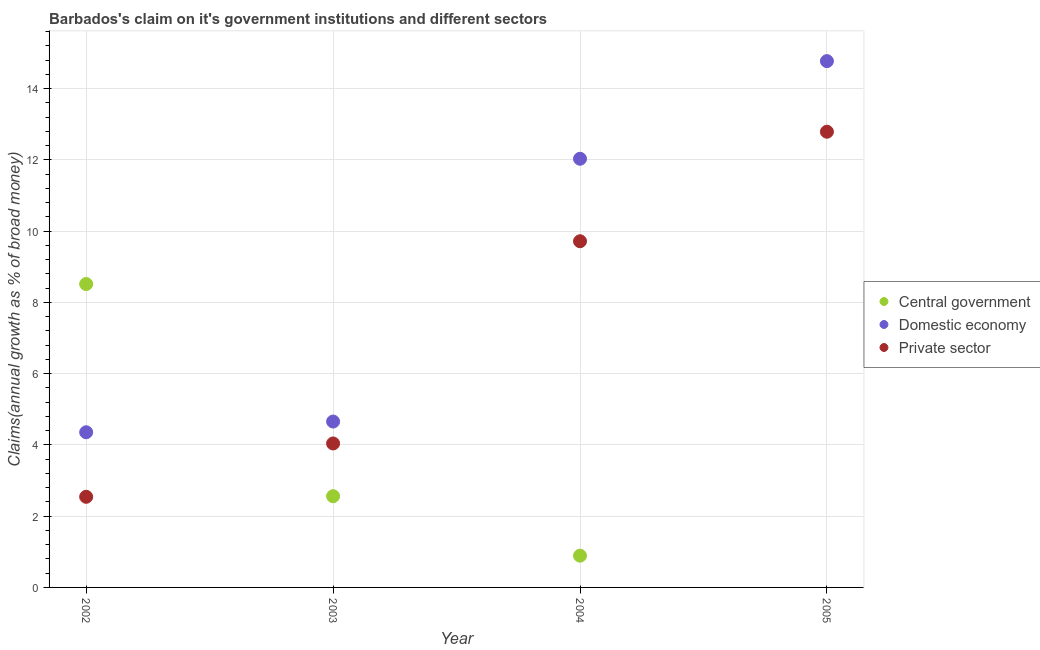Is the number of dotlines equal to the number of legend labels?
Give a very brief answer. No. What is the percentage of claim on the domestic economy in 2002?
Your answer should be very brief. 4.35. Across all years, what is the maximum percentage of claim on the central government?
Ensure brevity in your answer.  8.51. Across all years, what is the minimum percentage of claim on the domestic economy?
Give a very brief answer. 4.35. What is the total percentage of claim on the central government in the graph?
Ensure brevity in your answer.  11.97. What is the difference between the percentage of claim on the domestic economy in 2002 and that in 2004?
Your response must be concise. -7.68. What is the difference between the percentage of claim on the central government in 2003 and the percentage of claim on the private sector in 2004?
Give a very brief answer. -7.15. What is the average percentage of claim on the central government per year?
Your answer should be very brief. 2.99. In the year 2005, what is the difference between the percentage of claim on the domestic economy and percentage of claim on the private sector?
Your answer should be compact. 1.98. What is the ratio of the percentage of claim on the private sector in 2003 to that in 2005?
Offer a terse response. 0.32. Is the percentage of claim on the private sector in 2003 less than that in 2004?
Make the answer very short. Yes. What is the difference between the highest and the second highest percentage of claim on the domestic economy?
Provide a short and direct response. 2.74. What is the difference between the highest and the lowest percentage of claim on the domestic economy?
Your response must be concise. 10.42. Is the sum of the percentage of claim on the central government in 2002 and 2003 greater than the maximum percentage of claim on the domestic economy across all years?
Ensure brevity in your answer.  No. Is it the case that in every year, the sum of the percentage of claim on the central government and percentage of claim on the domestic economy is greater than the percentage of claim on the private sector?
Your answer should be very brief. Yes. Does the percentage of claim on the private sector monotonically increase over the years?
Give a very brief answer. Yes. Is the percentage of claim on the private sector strictly less than the percentage of claim on the central government over the years?
Offer a very short reply. No. How many years are there in the graph?
Give a very brief answer. 4. What is the difference between two consecutive major ticks on the Y-axis?
Ensure brevity in your answer.  2. Where does the legend appear in the graph?
Keep it short and to the point. Center right. How many legend labels are there?
Offer a very short reply. 3. What is the title of the graph?
Give a very brief answer. Barbados's claim on it's government institutions and different sectors. What is the label or title of the X-axis?
Ensure brevity in your answer.  Year. What is the label or title of the Y-axis?
Give a very brief answer. Claims(annual growth as % of broad money). What is the Claims(annual growth as % of broad money) of Central government in 2002?
Offer a terse response. 8.51. What is the Claims(annual growth as % of broad money) of Domestic economy in 2002?
Your answer should be compact. 4.35. What is the Claims(annual growth as % of broad money) of Private sector in 2002?
Offer a terse response. 2.54. What is the Claims(annual growth as % of broad money) of Central government in 2003?
Your response must be concise. 2.56. What is the Claims(annual growth as % of broad money) of Domestic economy in 2003?
Offer a terse response. 4.66. What is the Claims(annual growth as % of broad money) of Private sector in 2003?
Offer a terse response. 4.04. What is the Claims(annual growth as % of broad money) in Central government in 2004?
Your answer should be very brief. 0.89. What is the Claims(annual growth as % of broad money) in Domestic economy in 2004?
Keep it short and to the point. 12.03. What is the Claims(annual growth as % of broad money) in Private sector in 2004?
Offer a very short reply. 9.72. What is the Claims(annual growth as % of broad money) in Central government in 2005?
Offer a terse response. 0. What is the Claims(annual growth as % of broad money) in Domestic economy in 2005?
Offer a terse response. 14.77. What is the Claims(annual growth as % of broad money) of Private sector in 2005?
Keep it short and to the point. 12.79. Across all years, what is the maximum Claims(annual growth as % of broad money) of Central government?
Your answer should be compact. 8.51. Across all years, what is the maximum Claims(annual growth as % of broad money) in Domestic economy?
Offer a very short reply. 14.77. Across all years, what is the maximum Claims(annual growth as % of broad money) in Private sector?
Make the answer very short. 12.79. Across all years, what is the minimum Claims(annual growth as % of broad money) in Central government?
Your answer should be very brief. 0. Across all years, what is the minimum Claims(annual growth as % of broad money) of Domestic economy?
Offer a very short reply. 4.35. Across all years, what is the minimum Claims(annual growth as % of broad money) of Private sector?
Provide a succinct answer. 2.54. What is the total Claims(annual growth as % of broad money) of Central government in the graph?
Ensure brevity in your answer.  11.97. What is the total Claims(annual growth as % of broad money) in Domestic economy in the graph?
Offer a terse response. 35.81. What is the total Claims(annual growth as % of broad money) in Private sector in the graph?
Give a very brief answer. 29.09. What is the difference between the Claims(annual growth as % of broad money) of Central government in 2002 and that in 2003?
Give a very brief answer. 5.95. What is the difference between the Claims(annual growth as % of broad money) of Domestic economy in 2002 and that in 2003?
Offer a terse response. -0.3. What is the difference between the Claims(annual growth as % of broad money) of Private sector in 2002 and that in 2003?
Your answer should be compact. -1.5. What is the difference between the Claims(annual growth as % of broad money) in Central government in 2002 and that in 2004?
Offer a terse response. 7.62. What is the difference between the Claims(annual growth as % of broad money) in Domestic economy in 2002 and that in 2004?
Provide a succinct answer. -7.68. What is the difference between the Claims(annual growth as % of broad money) of Private sector in 2002 and that in 2004?
Provide a succinct answer. -7.17. What is the difference between the Claims(annual growth as % of broad money) of Domestic economy in 2002 and that in 2005?
Provide a succinct answer. -10.42. What is the difference between the Claims(annual growth as % of broad money) of Private sector in 2002 and that in 2005?
Ensure brevity in your answer.  -10.25. What is the difference between the Claims(annual growth as % of broad money) of Central government in 2003 and that in 2004?
Your answer should be very brief. 1.67. What is the difference between the Claims(annual growth as % of broad money) in Domestic economy in 2003 and that in 2004?
Make the answer very short. -7.37. What is the difference between the Claims(annual growth as % of broad money) in Private sector in 2003 and that in 2004?
Your response must be concise. -5.68. What is the difference between the Claims(annual growth as % of broad money) of Domestic economy in 2003 and that in 2005?
Keep it short and to the point. -10.12. What is the difference between the Claims(annual growth as % of broad money) of Private sector in 2003 and that in 2005?
Your answer should be very brief. -8.75. What is the difference between the Claims(annual growth as % of broad money) in Domestic economy in 2004 and that in 2005?
Your response must be concise. -2.74. What is the difference between the Claims(annual growth as % of broad money) of Private sector in 2004 and that in 2005?
Provide a succinct answer. -3.07. What is the difference between the Claims(annual growth as % of broad money) of Central government in 2002 and the Claims(annual growth as % of broad money) of Domestic economy in 2003?
Your answer should be compact. 3.86. What is the difference between the Claims(annual growth as % of broad money) in Central government in 2002 and the Claims(annual growth as % of broad money) in Private sector in 2003?
Make the answer very short. 4.47. What is the difference between the Claims(annual growth as % of broad money) of Domestic economy in 2002 and the Claims(annual growth as % of broad money) of Private sector in 2003?
Provide a succinct answer. 0.31. What is the difference between the Claims(annual growth as % of broad money) of Central government in 2002 and the Claims(annual growth as % of broad money) of Domestic economy in 2004?
Make the answer very short. -3.52. What is the difference between the Claims(annual growth as % of broad money) in Central government in 2002 and the Claims(annual growth as % of broad money) in Private sector in 2004?
Provide a short and direct response. -1.2. What is the difference between the Claims(annual growth as % of broad money) in Domestic economy in 2002 and the Claims(annual growth as % of broad money) in Private sector in 2004?
Make the answer very short. -5.36. What is the difference between the Claims(annual growth as % of broad money) in Central government in 2002 and the Claims(annual growth as % of broad money) in Domestic economy in 2005?
Offer a very short reply. -6.26. What is the difference between the Claims(annual growth as % of broad money) of Central government in 2002 and the Claims(annual growth as % of broad money) of Private sector in 2005?
Give a very brief answer. -4.27. What is the difference between the Claims(annual growth as % of broad money) in Domestic economy in 2002 and the Claims(annual growth as % of broad money) in Private sector in 2005?
Give a very brief answer. -8.43. What is the difference between the Claims(annual growth as % of broad money) of Central government in 2003 and the Claims(annual growth as % of broad money) of Domestic economy in 2004?
Offer a very short reply. -9.47. What is the difference between the Claims(annual growth as % of broad money) of Central government in 2003 and the Claims(annual growth as % of broad money) of Private sector in 2004?
Make the answer very short. -7.16. What is the difference between the Claims(annual growth as % of broad money) of Domestic economy in 2003 and the Claims(annual growth as % of broad money) of Private sector in 2004?
Offer a very short reply. -5.06. What is the difference between the Claims(annual growth as % of broad money) in Central government in 2003 and the Claims(annual growth as % of broad money) in Domestic economy in 2005?
Your answer should be compact. -12.21. What is the difference between the Claims(annual growth as % of broad money) of Central government in 2003 and the Claims(annual growth as % of broad money) of Private sector in 2005?
Your answer should be compact. -10.23. What is the difference between the Claims(annual growth as % of broad money) in Domestic economy in 2003 and the Claims(annual growth as % of broad money) in Private sector in 2005?
Ensure brevity in your answer.  -8.13. What is the difference between the Claims(annual growth as % of broad money) of Central government in 2004 and the Claims(annual growth as % of broad money) of Domestic economy in 2005?
Your response must be concise. -13.88. What is the difference between the Claims(annual growth as % of broad money) of Central government in 2004 and the Claims(annual growth as % of broad money) of Private sector in 2005?
Give a very brief answer. -11.9. What is the difference between the Claims(annual growth as % of broad money) of Domestic economy in 2004 and the Claims(annual growth as % of broad money) of Private sector in 2005?
Keep it short and to the point. -0.76. What is the average Claims(annual growth as % of broad money) of Central government per year?
Keep it short and to the point. 2.99. What is the average Claims(annual growth as % of broad money) of Domestic economy per year?
Ensure brevity in your answer.  8.95. What is the average Claims(annual growth as % of broad money) in Private sector per year?
Give a very brief answer. 7.27. In the year 2002, what is the difference between the Claims(annual growth as % of broad money) in Central government and Claims(annual growth as % of broad money) in Domestic economy?
Offer a terse response. 4.16. In the year 2002, what is the difference between the Claims(annual growth as % of broad money) in Central government and Claims(annual growth as % of broad money) in Private sector?
Give a very brief answer. 5.97. In the year 2002, what is the difference between the Claims(annual growth as % of broad money) in Domestic economy and Claims(annual growth as % of broad money) in Private sector?
Provide a succinct answer. 1.81. In the year 2003, what is the difference between the Claims(annual growth as % of broad money) in Central government and Claims(annual growth as % of broad money) in Domestic economy?
Offer a terse response. -2.1. In the year 2003, what is the difference between the Claims(annual growth as % of broad money) of Central government and Claims(annual growth as % of broad money) of Private sector?
Make the answer very short. -1.48. In the year 2003, what is the difference between the Claims(annual growth as % of broad money) of Domestic economy and Claims(annual growth as % of broad money) of Private sector?
Give a very brief answer. 0.62. In the year 2004, what is the difference between the Claims(annual growth as % of broad money) in Central government and Claims(annual growth as % of broad money) in Domestic economy?
Offer a very short reply. -11.14. In the year 2004, what is the difference between the Claims(annual growth as % of broad money) in Central government and Claims(annual growth as % of broad money) in Private sector?
Offer a terse response. -8.82. In the year 2004, what is the difference between the Claims(annual growth as % of broad money) of Domestic economy and Claims(annual growth as % of broad money) of Private sector?
Your answer should be very brief. 2.31. In the year 2005, what is the difference between the Claims(annual growth as % of broad money) in Domestic economy and Claims(annual growth as % of broad money) in Private sector?
Offer a very short reply. 1.98. What is the ratio of the Claims(annual growth as % of broad money) in Central government in 2002 to that in 2003?
Make the answer very short. 3.33. What is the ratio of the Claims(annual growth as % of broad money) of Domestic economy in 2002 to that in 2003?
Your response must be concise. 0.94. What is the ratio of the Claims(annual growth as % of broad money) in Private sector in 2002 to that in 2003?
Offer a very short reply. 0.63. What is the ratio of the Claims(annual growth as % of broad money) of Central government in 2002 to that in 2004?
Keep it short and to the point. 9.55. What is the ratio of the Claims(annual growth as % of broad money) in Domestic economy in 2002 to that in 2004?
Offer a terse response. 0.36. What is the ratio of the Claims(annual growth as % of broad money) in Private sector in 2002 to that in 2004?
Your response must be concise. 0.26. What is the ratio of the Claims(annual growth as % of broad money) of Domestic economy in 2002 to that in 2005?
Keep it short and to the point. 0.29. What is the ratio of the Claims(annual growth as % of broad money) of Private sector in 2002 to that in 2005?
Make the answer very short. 0.2. What is the ratio of the Claims(annual growth as % of broad money) in Central government in 2003 to that in 2004?
Offer a very short reply. 2.87. What is the ratio of the Claims(annual growth as % of broad money) in Domestic economy in 2003 to that in 2004?
Provide a short and direct response. 0.39. What is the ratio of the Claims(annual growth as % of broad money) in Private sector in 2003 to that in 2004?
Your answer should be compact. 0.42. What is the ratio of the Claims(annual growth as % of broad money) of Domestic economy in 2003 to that in 2005?
Make the answer very short. 0.32. What is the ratio of the Claims(annual growth as % of broad money) of Private sector in 2003 to that in 2005?
Your answer should be very brief. 0.32. What is the ratio of the Claims(annual growth as % of broad money) in Domestic economy in 2004 to that in 2005?
Your answer should be compact. 0.81. What is the ratio of the Claims(annual growth as % of broad money) in Private sector in 2004 to that in 2005?
Offer a terse response. 0.76. What is the difference between the highest and the second highest Claims(annual growth as % of broad money) of Central government?
Make the answer very short. 5.95. What is the difference between the highest and the second highest Claims(annual growth as % of broad money) of Domestic economy?
Offer a terse response. 2.74. What is the difference between the highest and the second highest Claims(annual growth as % of broad money) of Private sector?
Ensure brevity in your answer.  3.07. What is the difference between the highest and the lowest Claims(annual growth as % of broad money) of Central government?
Your answer should be compact. 8.51. What is the difference between the highest and the lowest Claims(annual growth as % of broad money) of Domestic economy?
Offer a very short reply. 10.42. What is the difference between the highest and the lowest Claims(annual growth as % of broad money) in Private sector?
Provide a short and direct response. 10.25. 